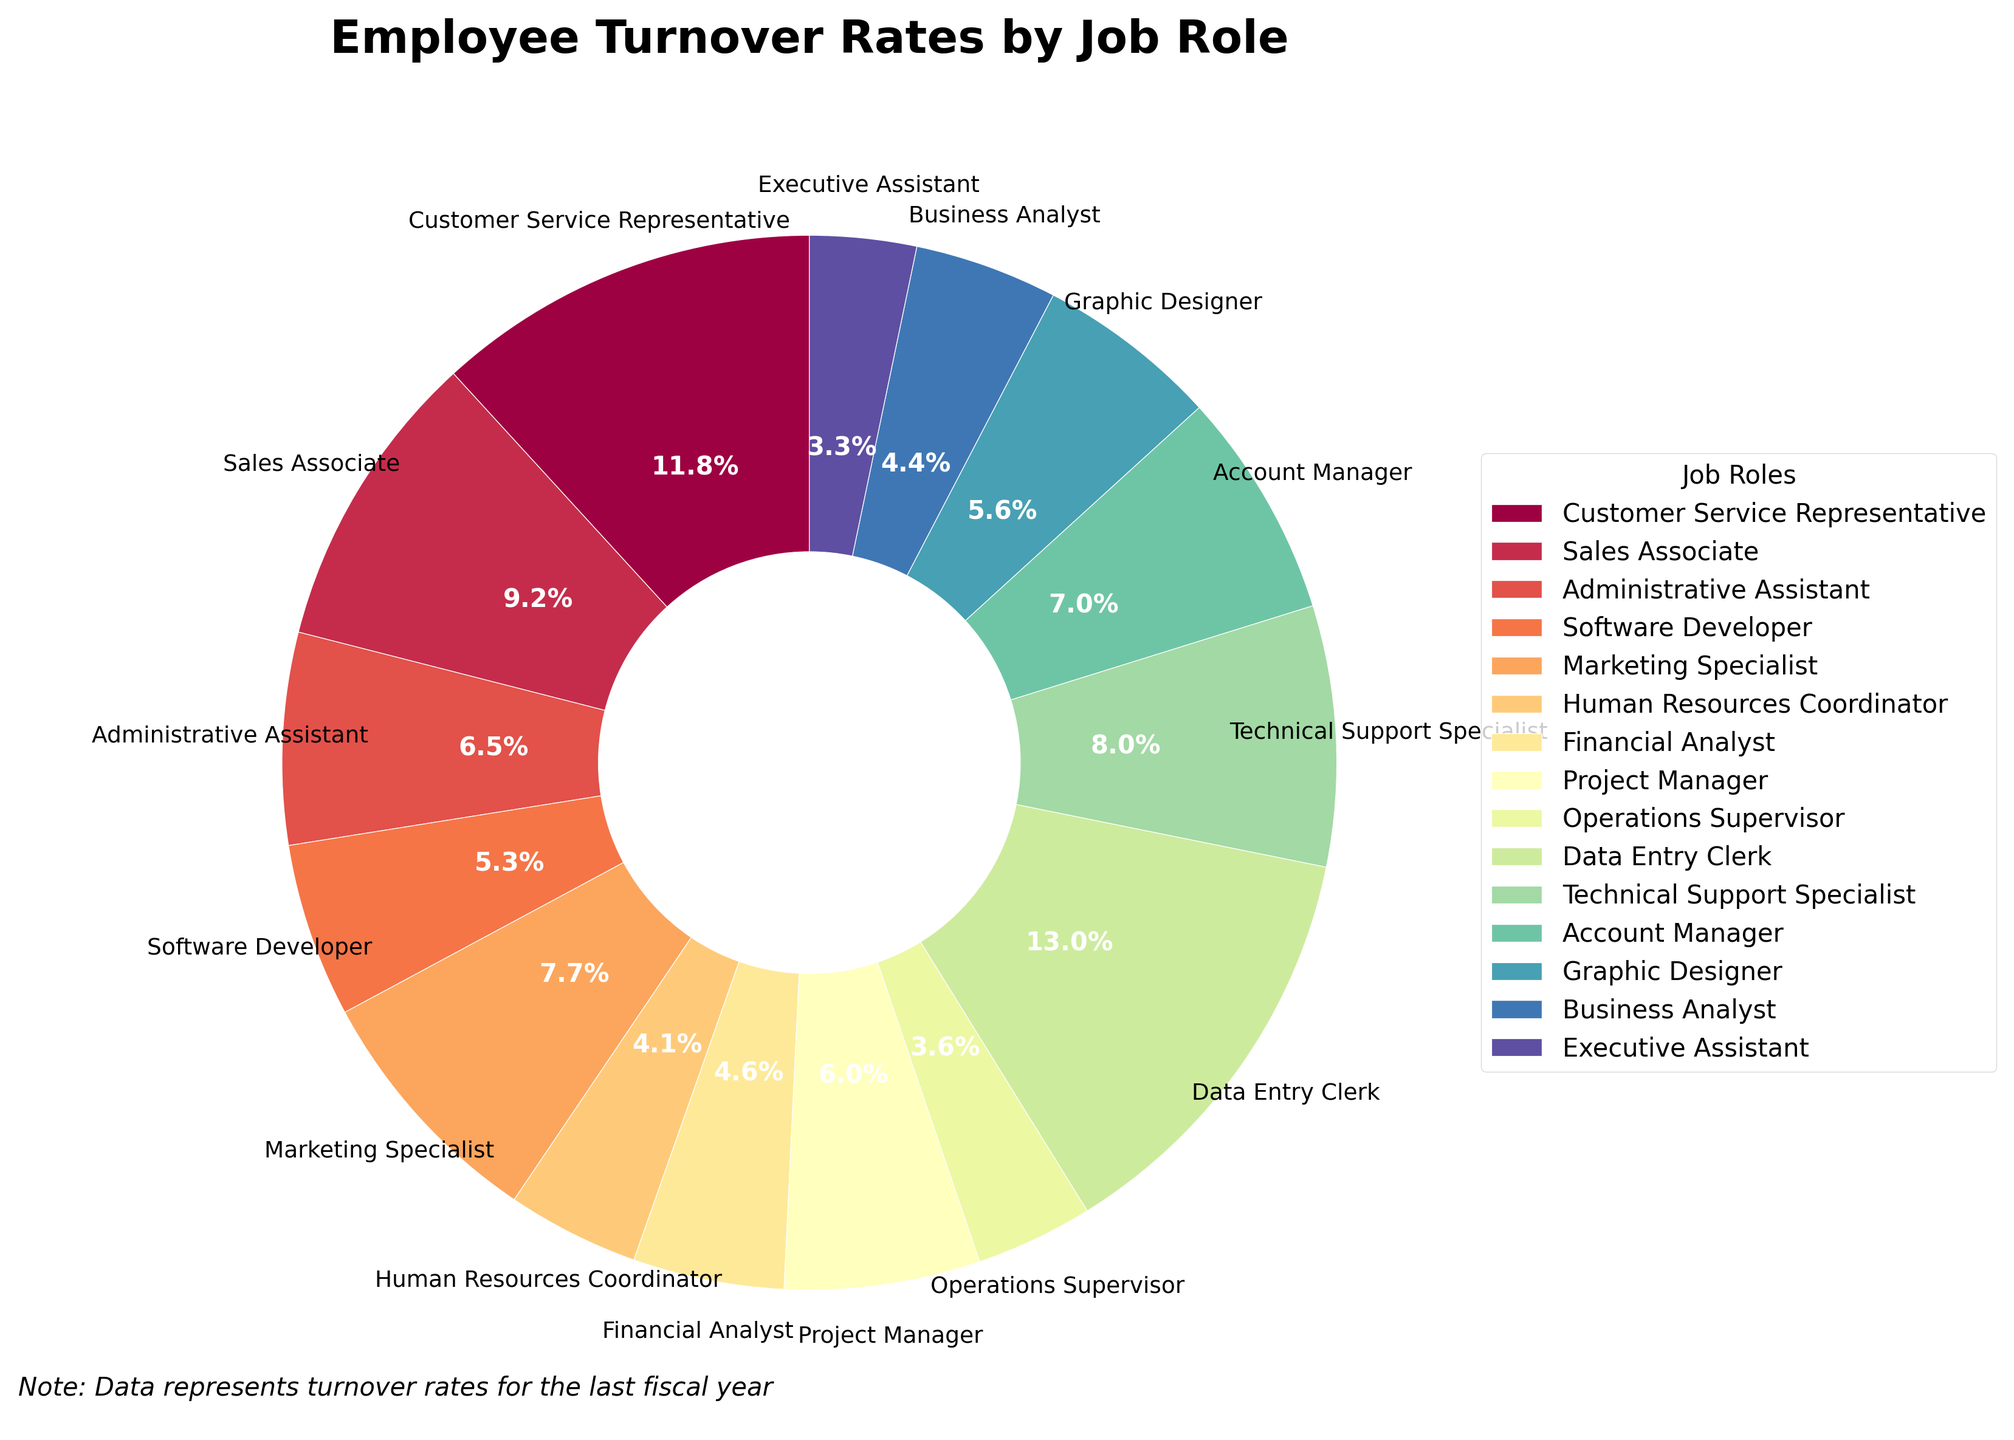What's the highest turnover rate among all job roles? The slice of the pie chart with the largest percentage text represents the highest turnover rate, which belongs to Data Entry Clerk at 31.4%.
Answer: Data Entry Clerk Which job role has a turnover rate lower than 10%? By examining the textual labels of the smaller slices, Human Resources Coordinator at 9.8%, Operations Supervisor at 8.7%, and Executive Assistant at 7.9% have turnover rates lower than 10%.
Answer: Human Resources Coordinator, Operations Supervisor, Executive Assistant What's the combined turnover rate of Customer Service Representative and Sales Associate? Each turnover rate is represented as a percentage text on the pie chart. Summing 28.5% (Customer Service Representative) and 22.3% (Sales Associate) gives 50.8%.
Answer: 50.8% Is the turnover rate of Software Developer higher than that of Graphic Designer? By comparing the percentage texts directly in the pie chart, Software Developer has a turnover rate of 12.9%, whereas Graphic Designer has a turnover rate of 13.5%. Software Developer's rate is therefore lower.
Answer: No Which job role has the most similar turnover rate to Marketing Specialist? By scanning the percentage texts, both Marketing Specialist (18.6%) and Technical Support Specialist (19.3%) have close turnover rates, with a difference of only 0.7%.
Answer: Technical Support Specialist What's the difference in turnover rates between the job role with the highest and the lowest rates? The highest turnover rate is Data Entry Clerk at 31.4%, and the lowest is Executive Assistant at 7.9%. The difference is calculated as 31.4% - 7.9% = 23.5%.
Answer: 23.5% Which job role had the least turnover last year? The pie chart's smallest slice corresponds to Executive Assistant with a turnover rate of 7.9%.
Answer: Executive Assistant How much higher is the turnover rate of Data Entry Clerk compared to Operations Supervisor? Data Entry Clerk has a turnover rate of 31.4% and Operations Supervisor has 8.7%. The difference is 31.4% - 8.7% = 22.7%.
Answer: 22.7% What's the average turnover rate of the Technical Support Specialist, Financial Analyst, and Account Manager? Sum the turnover rates of Technical Support Specialist (19.3%), Financial Analyst (11.2%), and Account Manager (16.8%) to get a total of 47.3%, then divide by 3. 47.3 / 3 = 15.77%.
Answer: 15.77% 